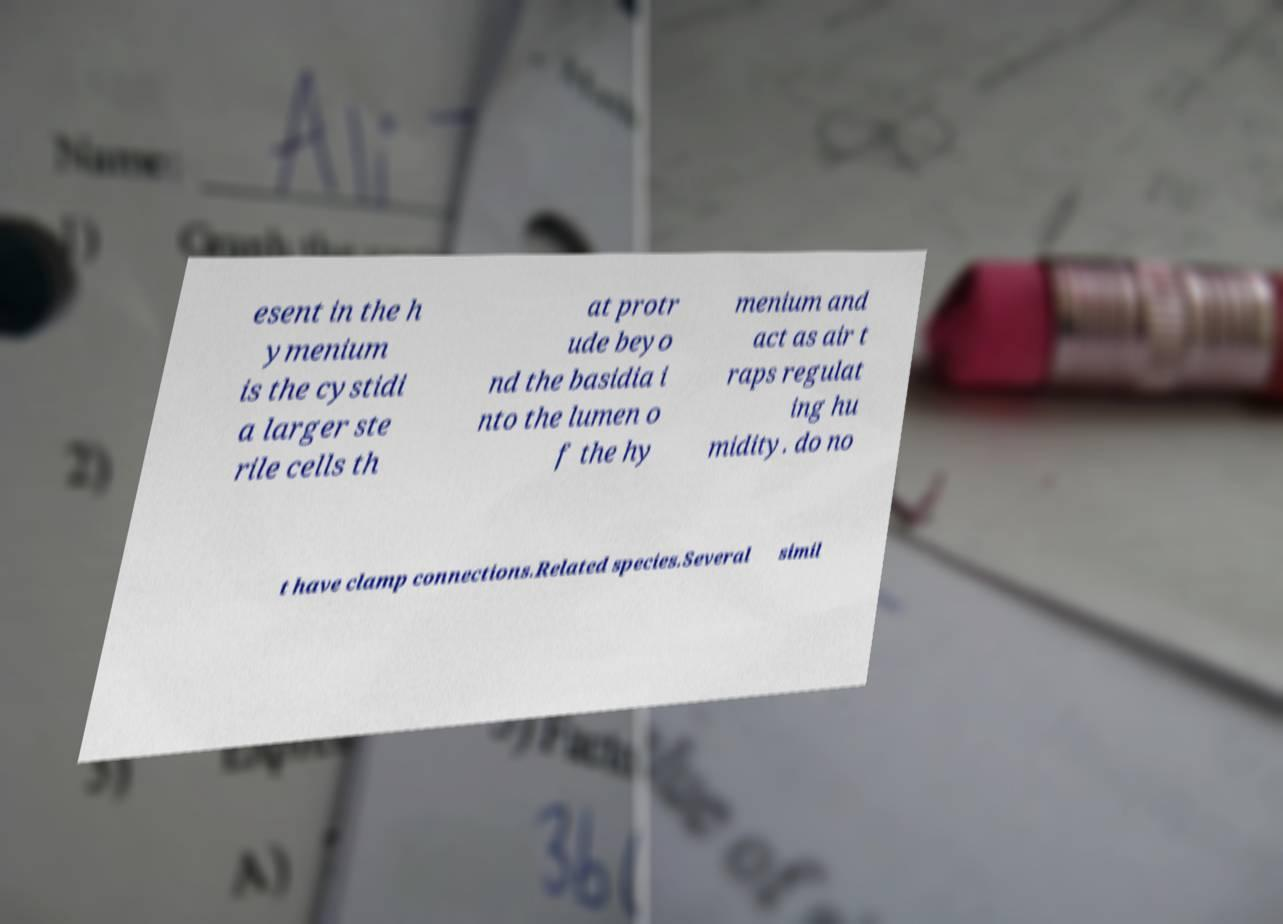What messages or text are displayed in this image? I need them in a readable, typed format. esent in the h ymenium is the cystidi a larger ste rile cells th at protr ude beyo nd the basidia i nto the lumen o f the hy menium and act as air t raps regulat ing hu midity. do no t have clamp connections.Related species.Several simil 